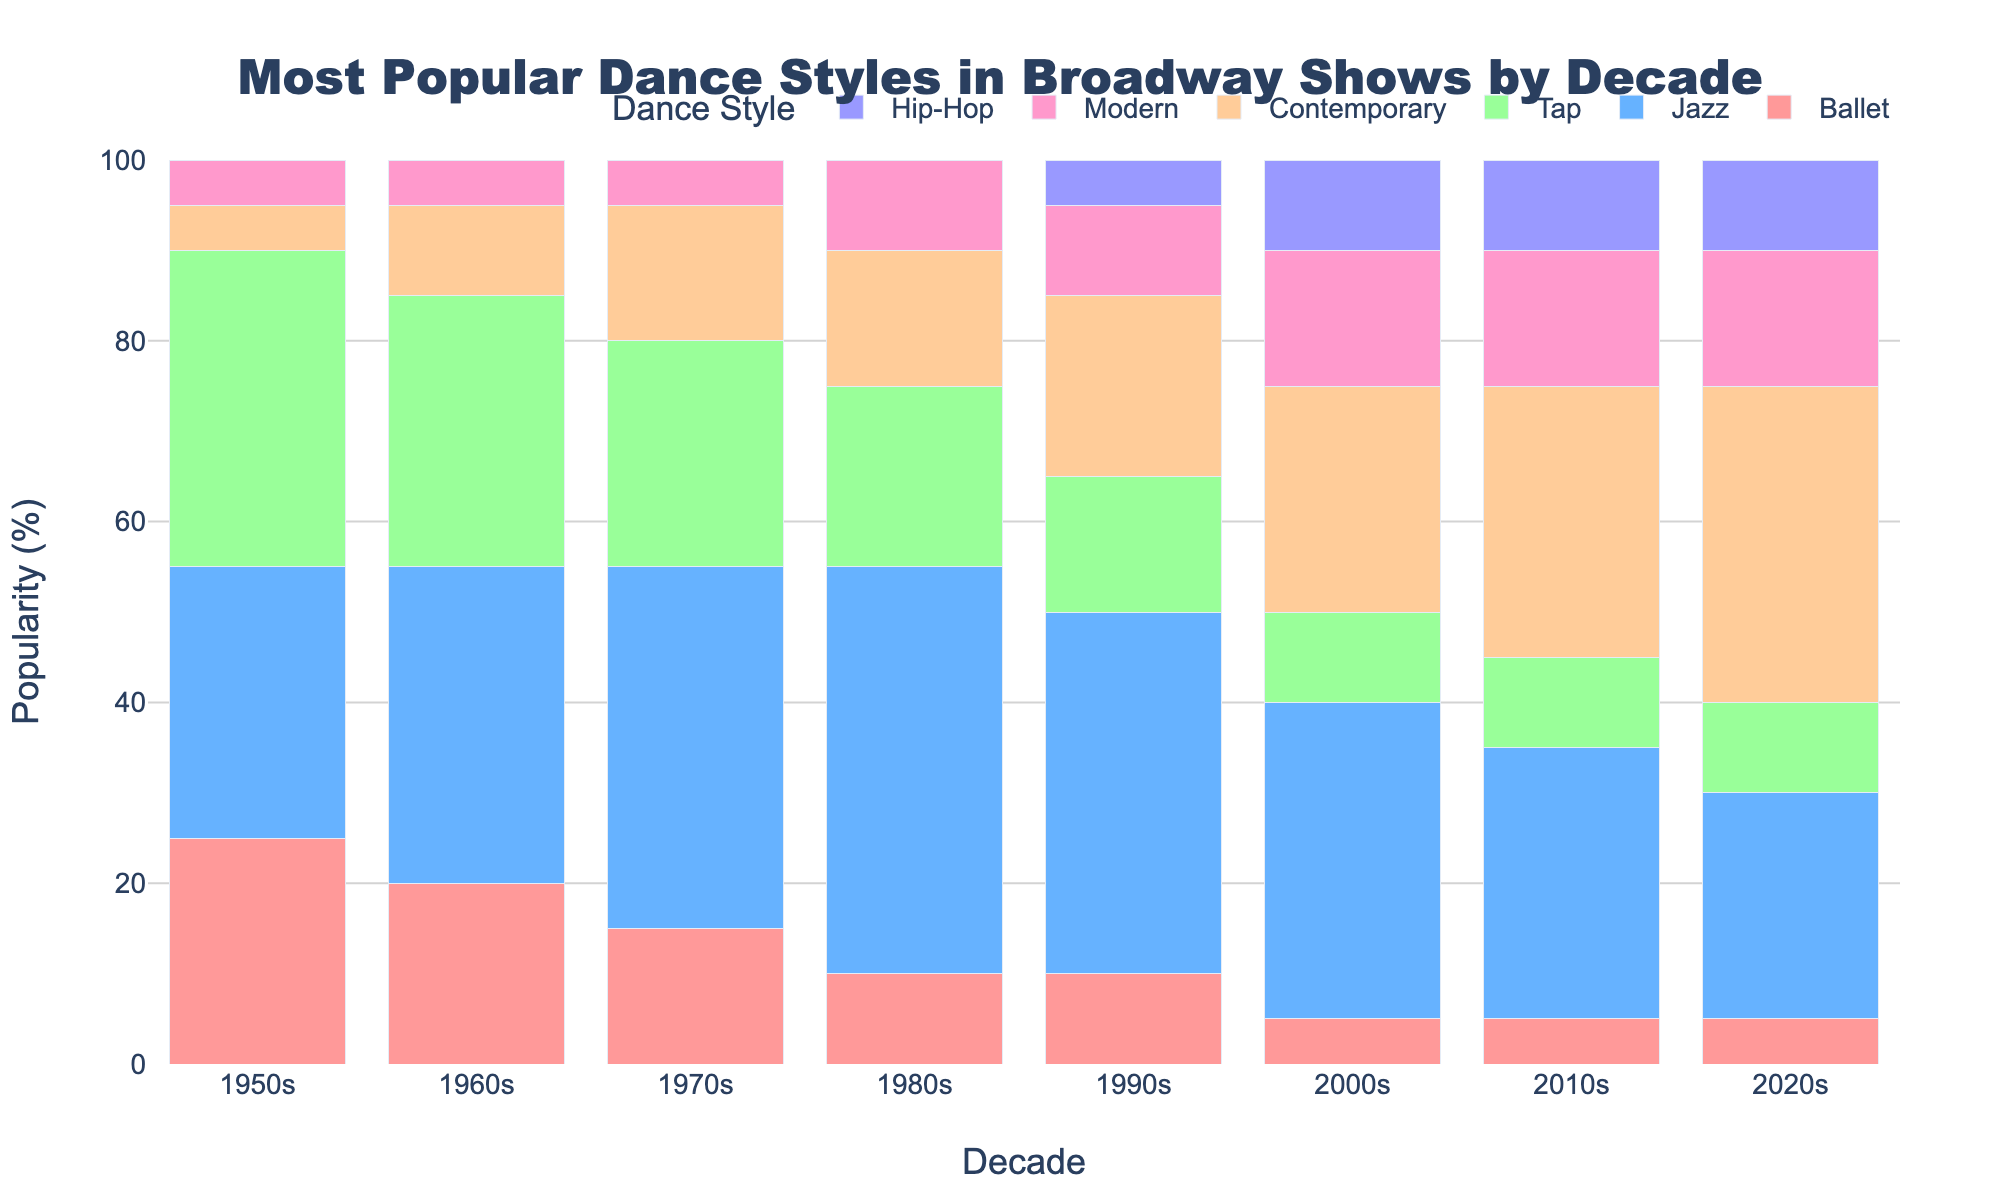What is the most popular dance style in the 1950s? Looking at the figure, identify the tallest bar in the 1950s section, which represents the most popular dance style.
Answer: Tap Which decade had the highest popularity percentage for Contemporary dance? Locate the bars representing Contemporary dance across all decades and identify the tallest one. The tallest bar indicates the highest popularity percentage.
Answer: 2020s Compare the popularity of Ballet in the 1980s and 2010s. Identify the bar heights for Ballet in the 1980s and 2010s and compare the values. Ballet in the 1980s is 10%, and in the 2010s, it is 5%.
Answer: Ballet was more popular in the 1980s By how much did the popularity of Jazz dance change from the 1950s to the 1970s? Identify the bar heights for Jazz in the 1950s (30%) and 1970s (40%), then calculate the difference: 40% - 30% = 10%.
Answer: Increased by 10% What is the combined popularity of Tap and Hip-Hop in the 2000s? Locate the bar heights for Tap (10%) and Hip-Hop (10%) in the 2000s, then sum them: 10% + 10% = 20%.
Answer: 20% Which dance style has consistently declined in popularity from the 1950s to the 2020s? Analyze the trend for each dance style from the 1950s to the 2020s and identify the one with a consistently decreasing trend. Ballet's popularity decreases over time.
Answer: Ballet How did the popularity of Modern dance change from the 1980s to the 2020s? Identify the bar heights for Modern dance in the 1980s (10%) and 2020s (15%), then compare the values: 15% - 10% = 5%.
Answer: Increased by 5% What is the second most popular dance style in the 1960s? In the 1960s section, locate the top two tallest bars. Jazz (35%) is the tallest, making Tap (30%) the second most popular.
Answer: Tap In which decade did Hip-Hop first appear in Broadway shows? Identify the first decade where the Hip-Hop bar appears (has a non-zero height). Hip-Hop first appears in the 1990s.
Answer: 1990s 